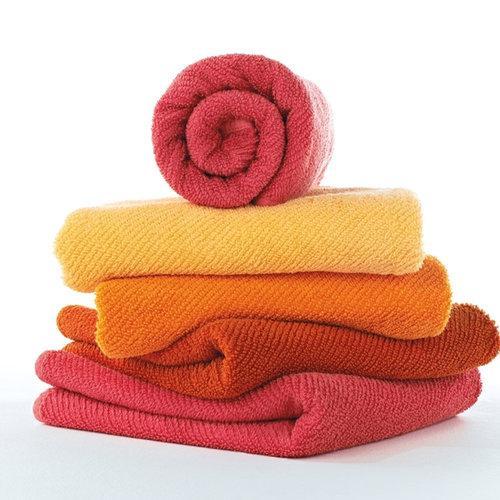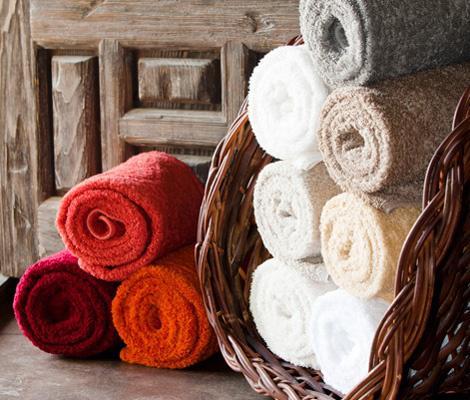The first image is the image on the left, the second image is the image on the right. Given the left and right images, does the statement "There is at least one stack of regularly folded towels in each image, with at least 3 different colors of towel per image." hold true? Answer yes or no. No. The first image is the image on the left, the second image is the image on the right. Considering the images on both sides, is "There is a least two towers of four towels." valid? Answer yes or no. No. 